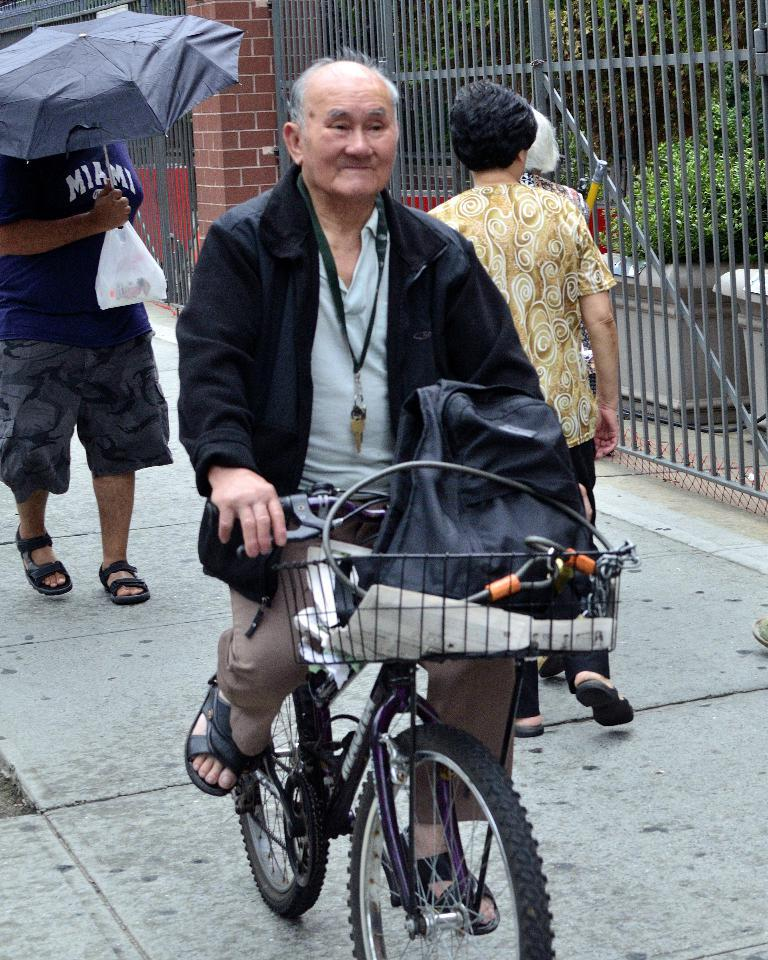What is the person in the image wearing? The person in the image is wearing a black jacket. What activity is the person in the image engaged in? The person is riding a bicycle. Can you describe the person behind the person on the bicycle? There is a woman behind the person on the bicycle. What is the person in the left corner of the image holding? The person in the left corner of the image is holding an umbrella. How many spiders are crawling on the person riding the bicycle in the image? There are no spiders visible in the image; the person is riding a bicycle and wearing a black jacket. 